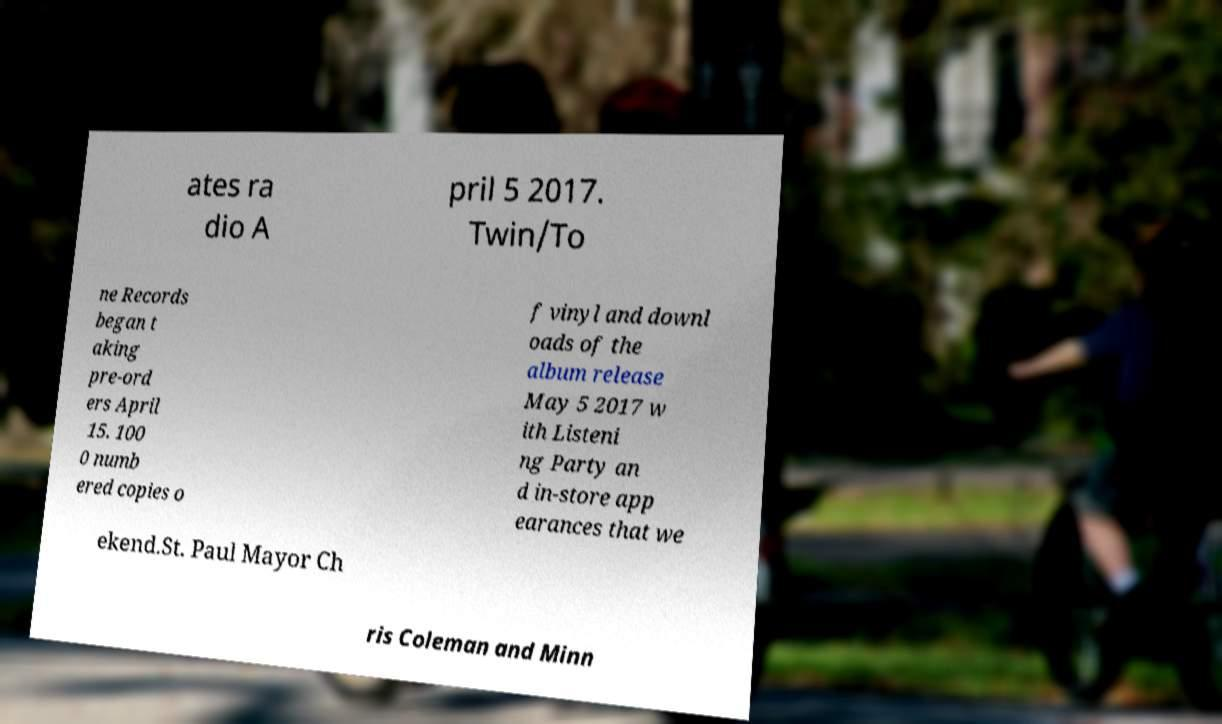Can you read and provide the text displayed in the image?This photo seems to have some interesting text. Can you extract and type it out for me? ates ra dio A pril 5 2017. Twin/To ne Records began t aking pre-ord ers April 15. 100 0 numb ered copies o f vinyl and downl oads of the album release May 5 2017 w ith Listeni ng Party an d in-store app earances that we ekend.St. Paul Mayor Ch ris Coleman and Minn 